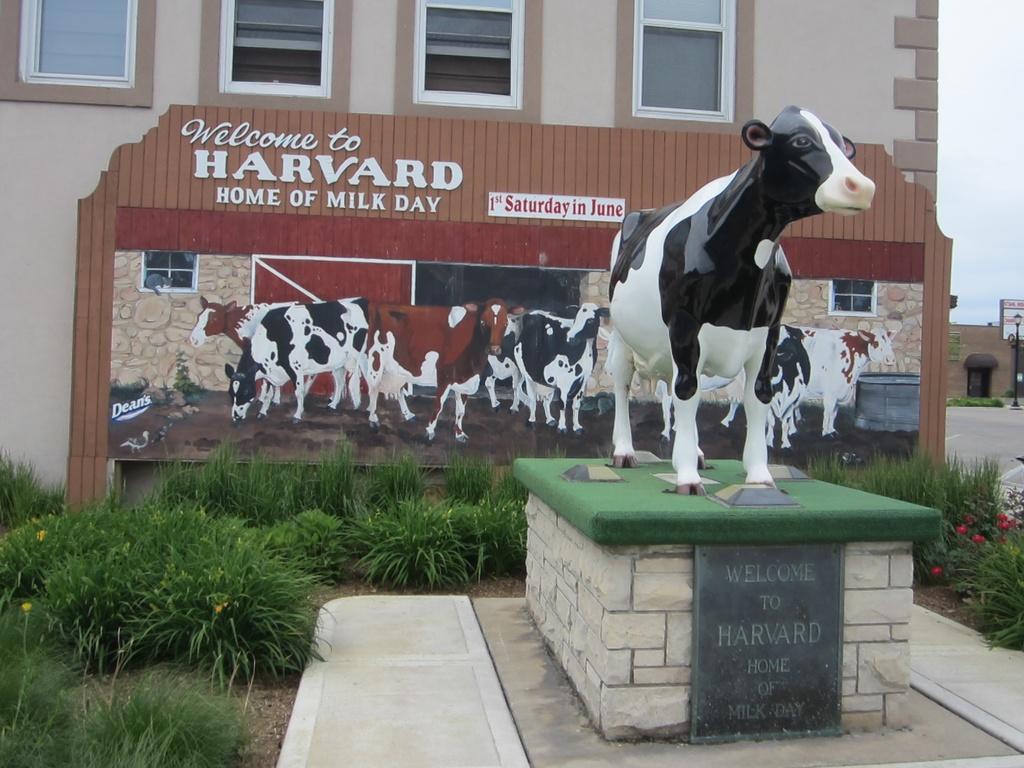Please provide a concise description of this image. In this image at the center there is a statue of the buffalo. At the bottom of the image there are plants with the flowers on it. Behind the plants there is a wooden board. On the backside there are buildings. On the right side of the image there is a street light. 